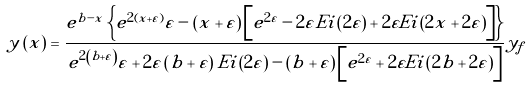<formula> <loc_0><loc_0><loc_500><loc_500>y \left ( x \right ) = \frac { { e ^ { b - x } \left \{ { e ^ { 2 \left ( { x + \varepsilon } \right ) } \varepsilon - \left ( { x + \varepsilon } \right ) \left [ { e ^ { 2 \varepsilon } - 2 \varepsilon { E i } \left ( { 2 \varepsilon } \right ) + 2 \varepsilon E i \left ( { 2 x + 2 \varepsilon } \right ) } \right ] } \right \} } } { { e ^ { 2 \left ( { b + \varepsilon } \right ) } \varepsilon + 2 \varepsilon \left ( { b + \varepsilon } \right ) E i \left ( { 2 \varepsilon } \right ) - \left ( { b + \varepsilon } \right ) \left [ { e ^ { 2 \varepsilon } + 2 \varepsilon E i \left ( { 2 b + 2 \varepsilon } \right ) } \right ] } } y _ { f }</formula> 